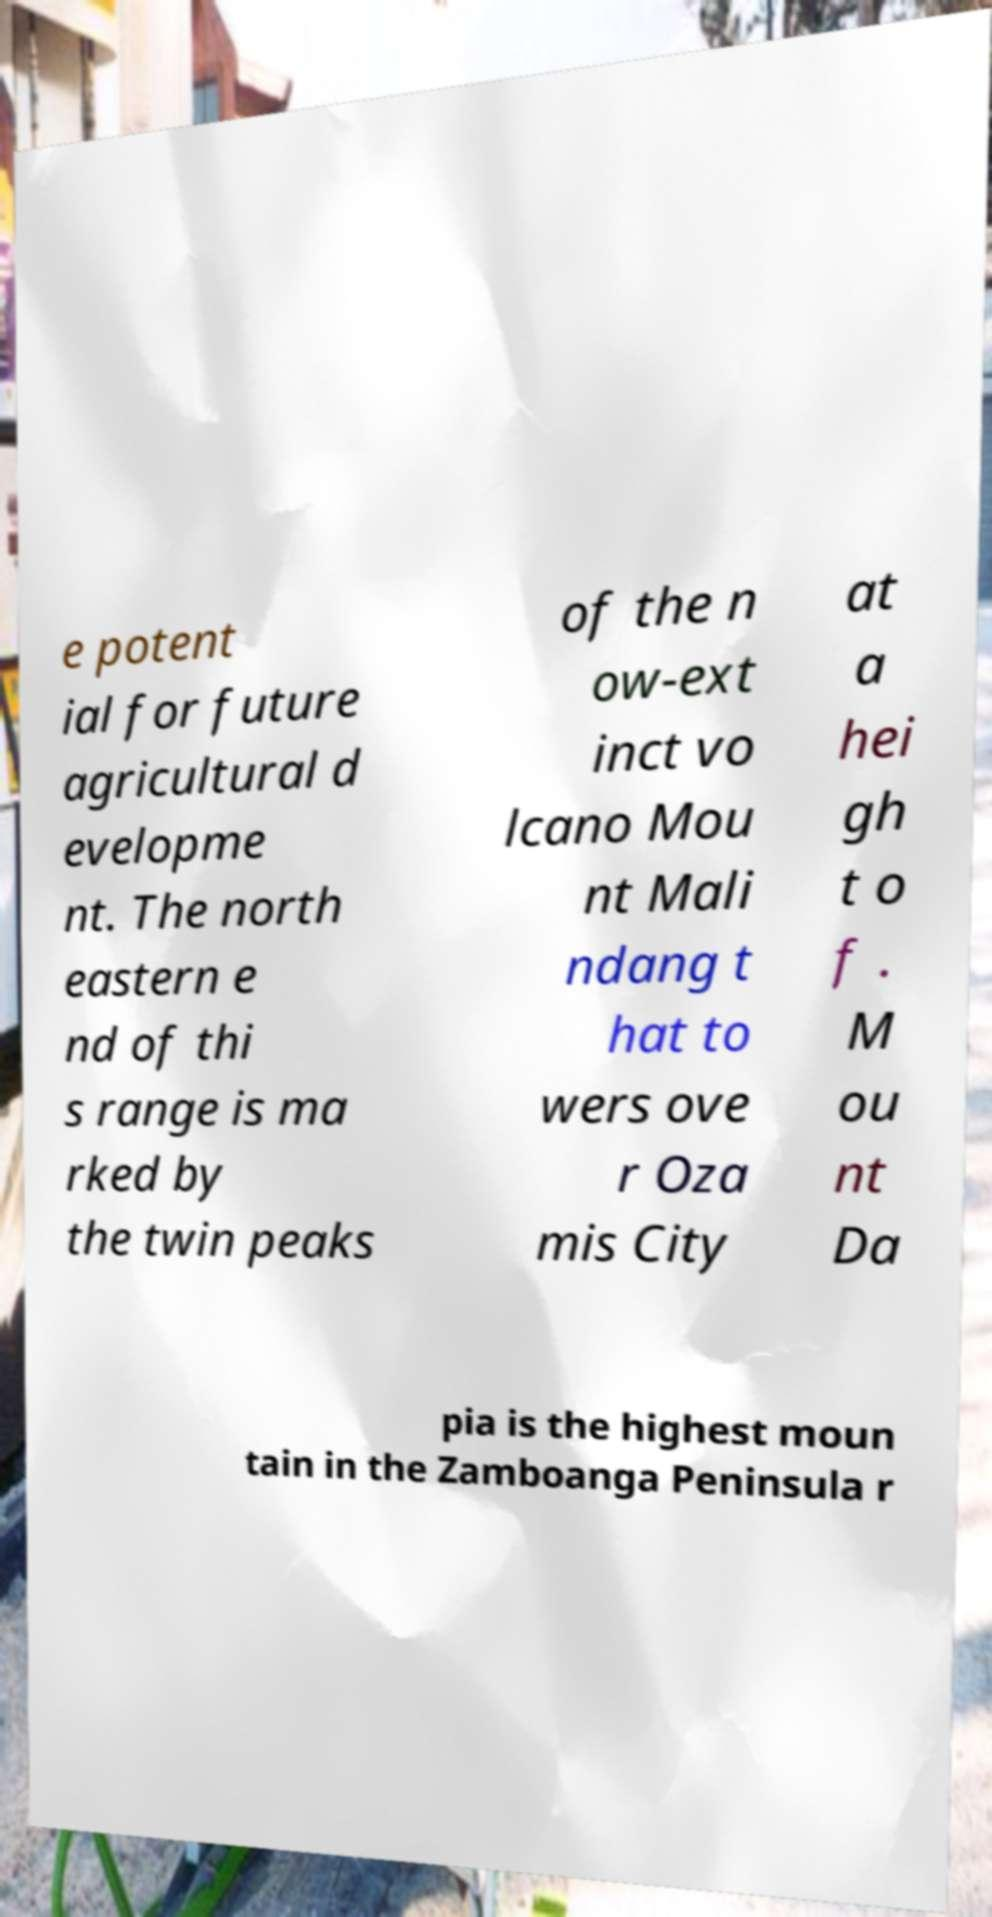Please read and relay the text visible in this image. What does it say? e potent ial for future agricultural d evelopme nt. The north eastern e nd of thi s range is ma rked by the twin peaks of the n ow-ext inct vo lcano Mou nt Mali ndang t hat to wers ove r Oza mis City at a hei gh t o f . M ou nt Da pia is the highest moun tain in the Zamboanga Peninsula r 